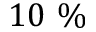Convert formula to latex. <formula><loc_0><loc_0><loc_500><loc_500>1 0 \%</formula> 